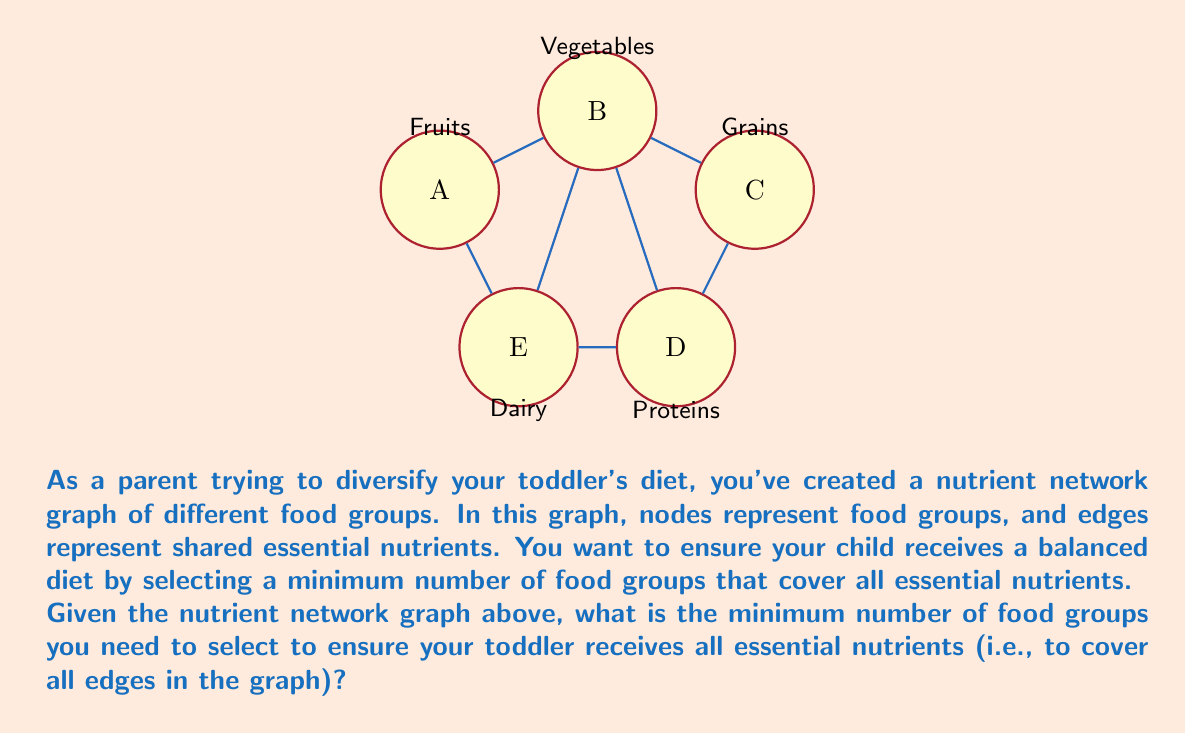Could you help me with this problem? To solve this problem, we need to find the minimum vertex cover of the given graph. A vertex cover is a set of vertices such that each edge of the graph is incident to at least one vertex in the set.

Let's approach this step-by-step:

1) First, observe that the graph has 5 vertices (food groups) and 7 edges (shared nutrients).

2) We can see that vertex B (Vegetables) is connected to all other vertices. This suggests that B might be a good candidate for our cover.

3) If we select B, we cover 4 edges: A-B, B-C, B-D, and B-E.

4) The only remaining edge not covered by B is C-D.

5) To cover C-D, we need to select either C or D.

6) Therefore, the minimum vertex cover consists of B (Vegetables) and either C (Grains) or D (Proteins).

7) The size of this minimum vertex cover is 2.

Mathematically, we can express the vertex cover as:

$$ \text{Vertex Cover} = \{B, C\} \text{ or } \{B, D\} $$

This means that by selecting either Vegetables and Grains, or Vegetables and Proteins, we ensure that all essential nutrients are covered in your toddler's diet.
Answer: 2 